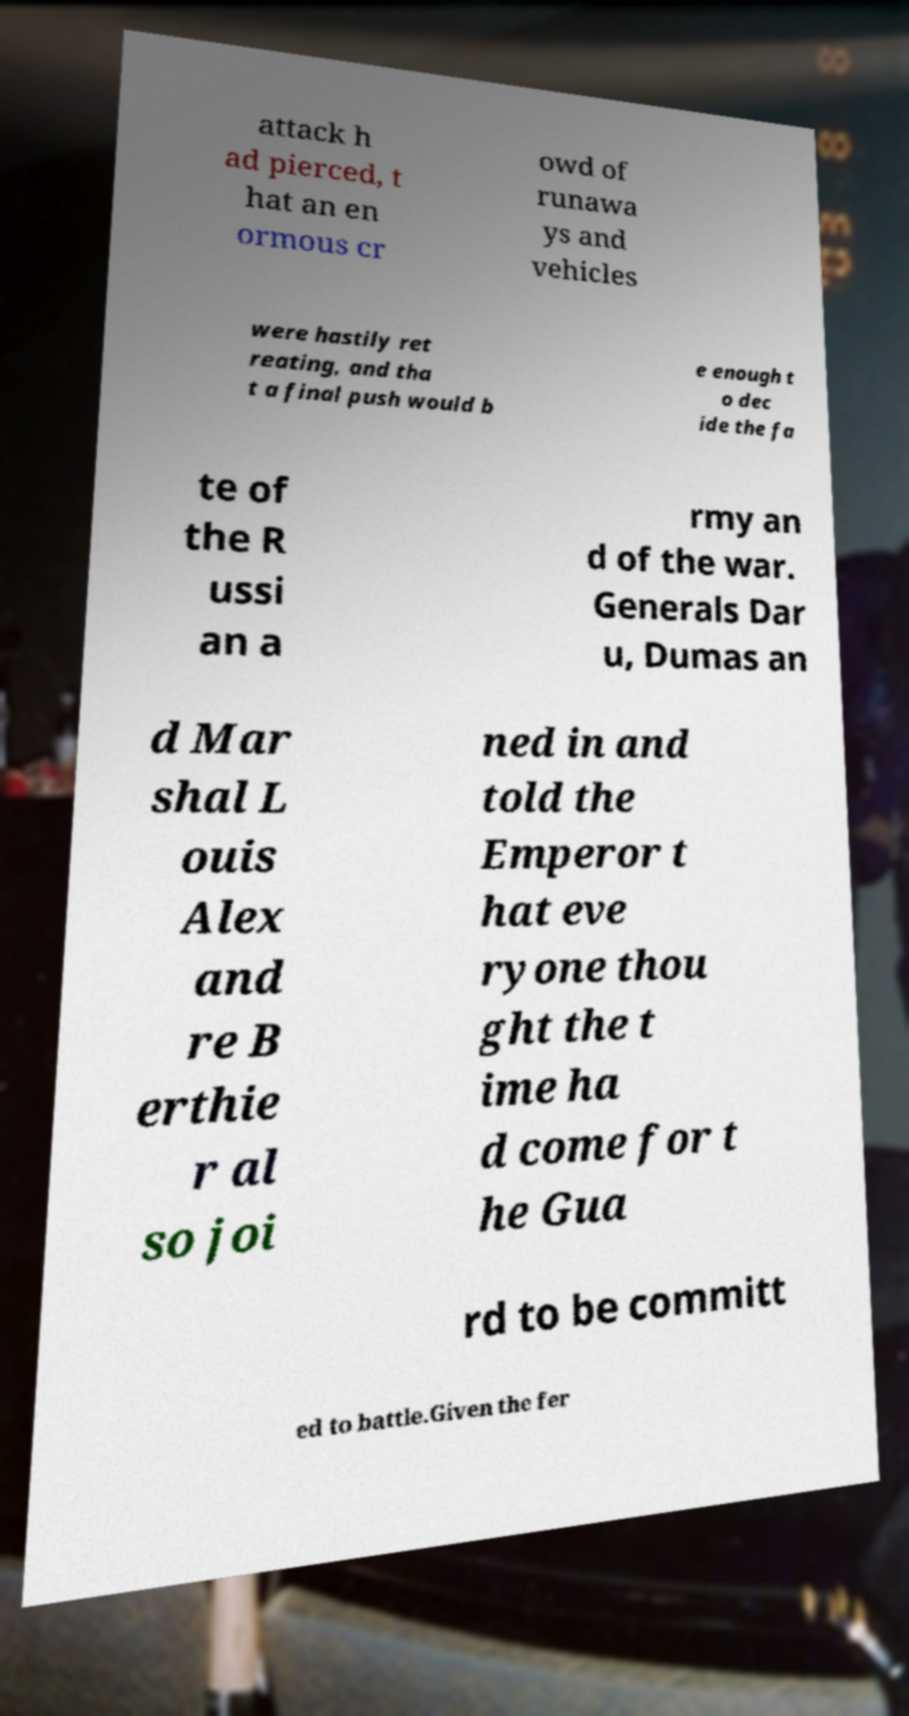Please identify and transcribe the text found in this image. attack h ad pierced, t hat an en ormous cr owd of runawa ys and vehicles were hastily ret reating, and tha t a final push would b e enough t o dec ide the fa te of the R ussi an a rmy an d of the war. Generals Dar u, Dumas an d Mar shal L ouis Alex and re B erthie r al so joi ned in and told the Emperor t hat eve ryone thou ght the t ime ha d come for t he Gua rd to be committ ed to battle.Given the fer 